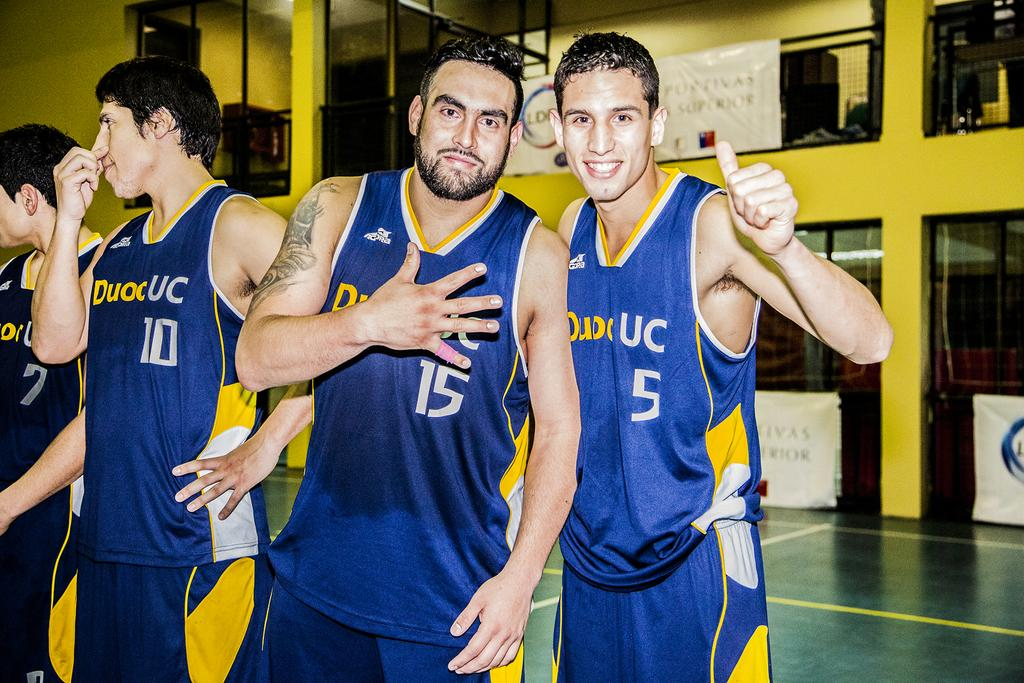<image>
Offer a succinct explanation of the picture presented. Four UC basketball team with 2 players giving gratitude. 